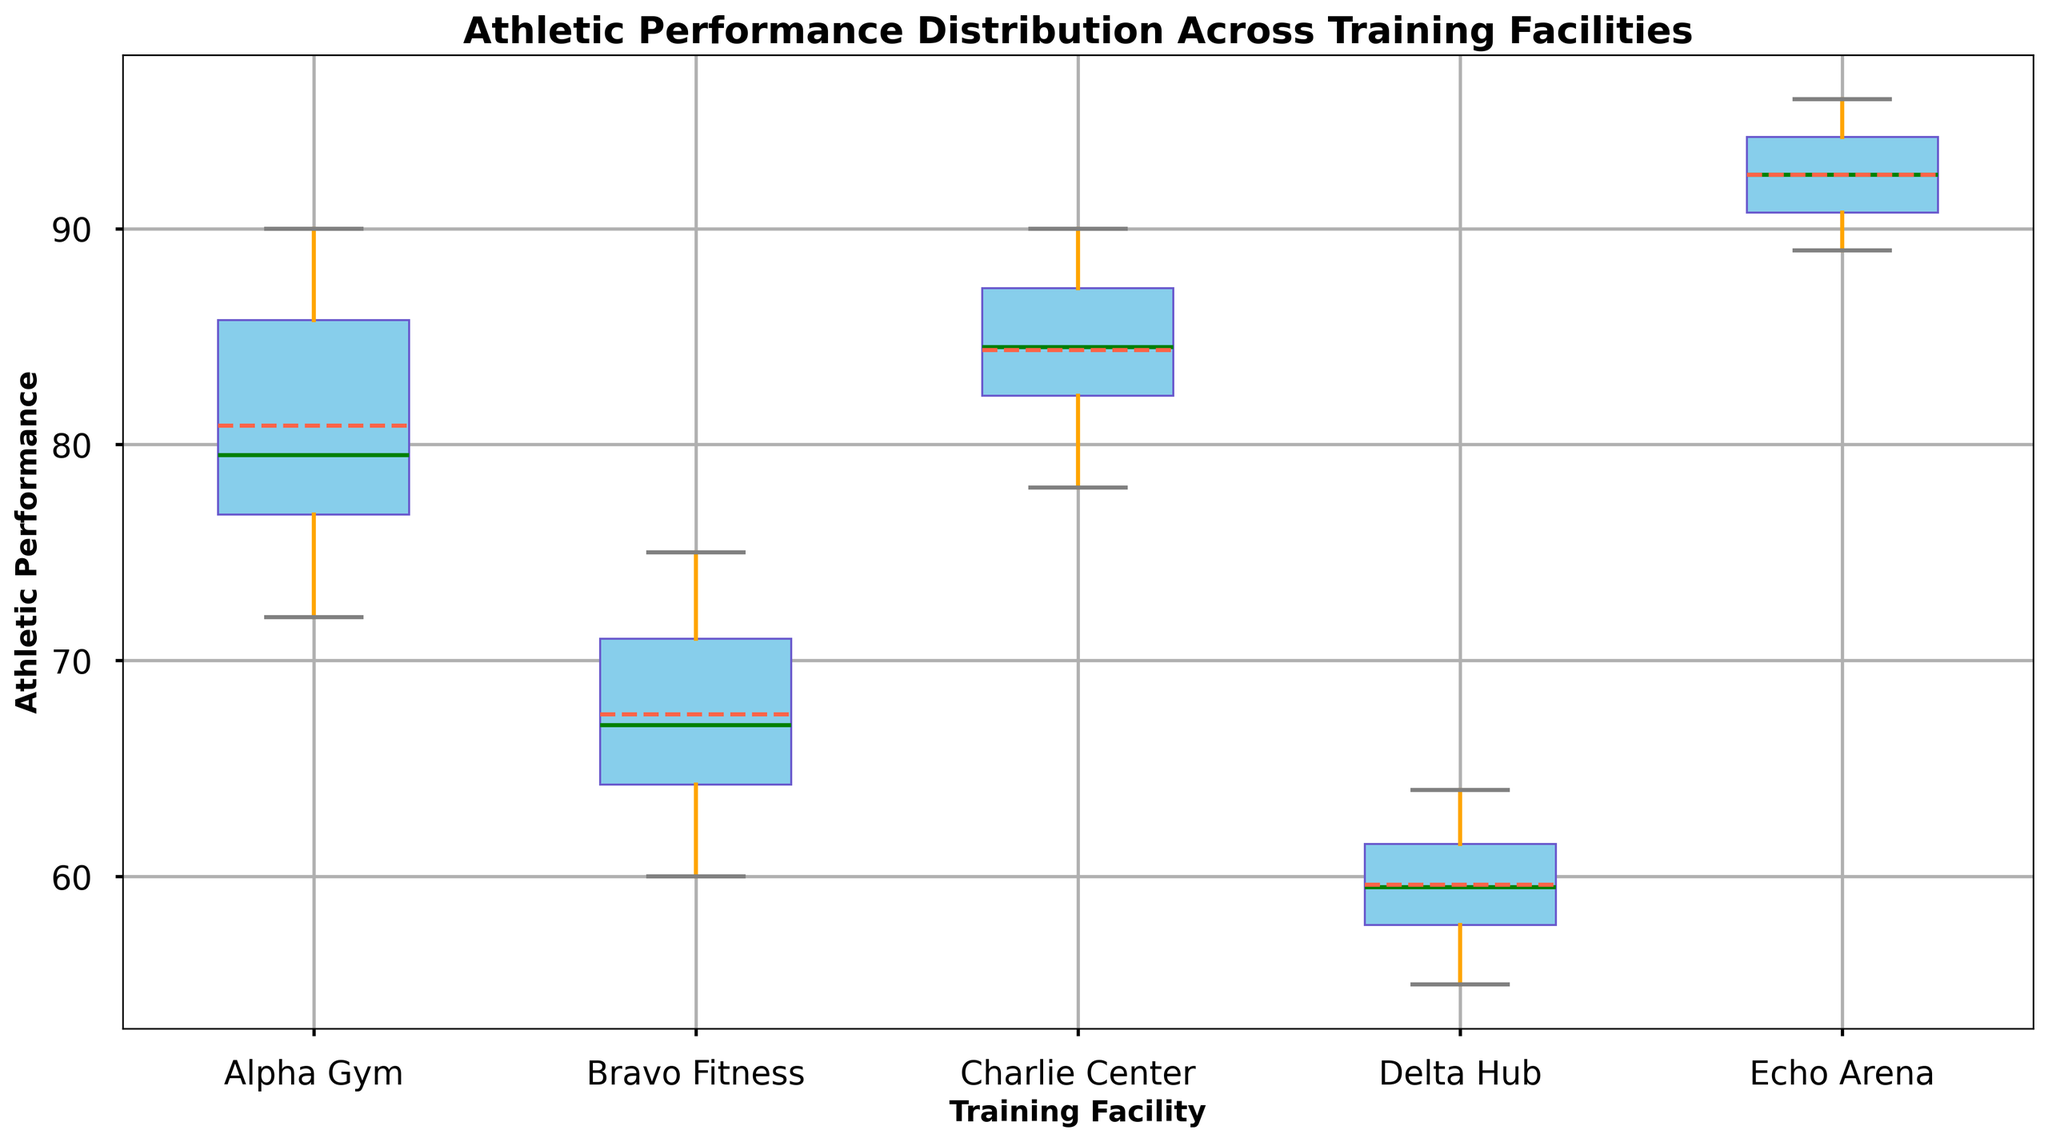what's the range of athletic performance at Alpha Gym? The range can be calculated by subtracting the minimum value from the maximum value. For Alpha Gym, the minimum value is 72, and the maximum value is 90. So, the range is 90 - 72 = 18
Answer: 18 Which training facility has the highest median athletic performance? To find the facility with the highest median, compare the median values for each facility. Echo Arena has the highest median as indicated by the green line closest to the top of the box.
Answer: Echo Arena Which training facility has the largest interquartile range (IQR) in athletic performance? The IQR is the difference between the third quartile (Q3) and the first quartile (Q1). By visually comparing the length of the boxes, Echo Arena has the largest IQR as its box is widest vertically.
Answer: Echo Arena Is the mean athletic performance higher or lower than the median at Bravo Fitness? The mean is depicted by the red line, and the median by the green line. Visually, the red mean line at Bravo Fitness is below the green median line.
Answer: Lower Which training facility has the smallest variability in athletic performance? The smallest variability can be observed by looking at the overall length of the whiskers. Delta Hub has the shortest whiskers, indicating the smallest variability.
Answer: Delta Hub Compare the upper whisker length of Charlie Center and Echo Arena. Which is longer? Visually compare the length of the upper whiskers (lines extending above the boxes). The upper whisker of Echo Arena is longer than that of Charlie Center.
Answer: Echo Arena What is the median athletic performance at Delta Hub? The median is represented by the green line inside the box for Delta Hub. By locating this green line, it corresponds roughly to the value of 59.
Answer: 59 How many facilities have a median athletic performance of 85 or higher? Visually count the green lines that are at or above the value of 85. Both Charlie Center and Echo Arena have their medians at or above 85.
Answer: 2 Between Alpha Gym and Bravo Fitness, which has a higher third quartile (Q3) value? The third quartile (Q3) is the top of the box. By comparing the boxes, Alpha Gym's Q3 is higher than Bravo Fitness's.
Answer: Alpha Gym Which training facility has the highest maximum athletic performance? The highest maximum is indicated by the top end of the upper whisker. Echo Arena has the highest maximum value reaching 96.
Answer: Echo Arena 